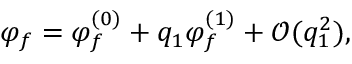Convert formula to latex. <formula><loc_0><loc_0><loc_500><loc_500>\varphi _ { f } = \varphi _ { f } ^ { ( 0 ) } + q _ { 1 } \varphi _ { f } ^ { ( 1 ) } + \mathcal { O } ( q _ { 1 } ^ { 2 } ) ,</formula> 